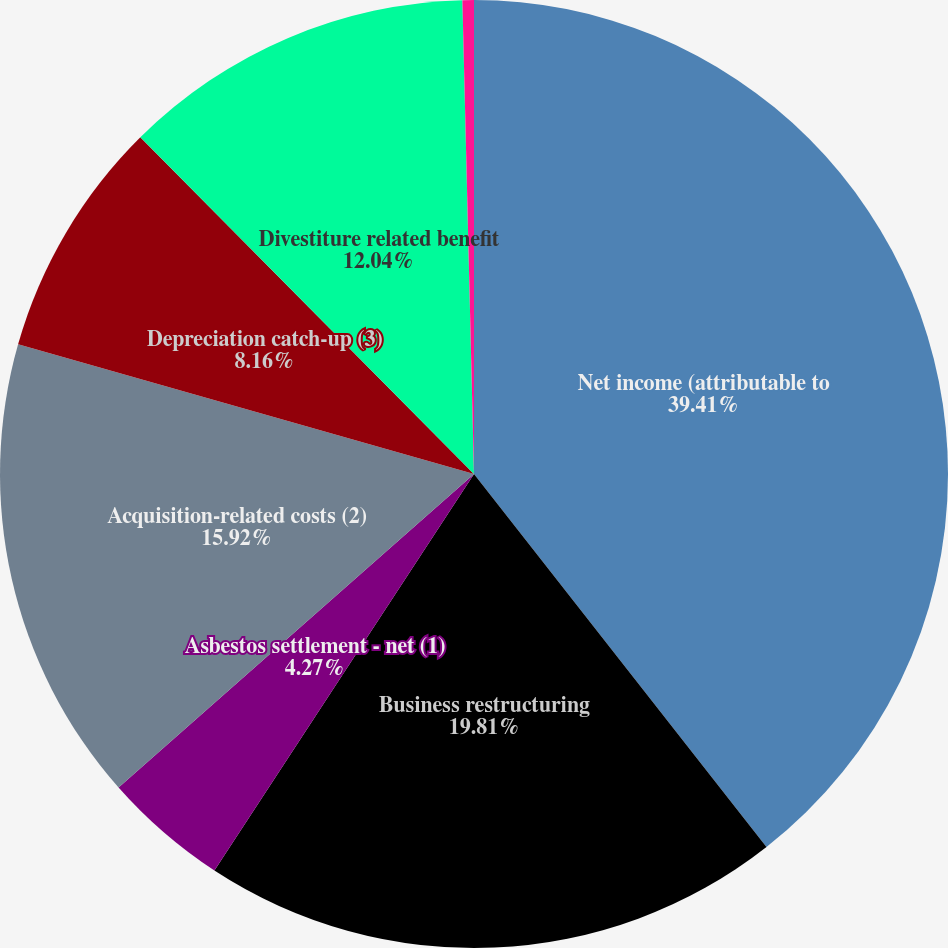<chart> <loc_0><loc_0><loc_500><loc_500><pie_chart><fcel>Net income (attributable to<fcel>Business restructuring<fcel>Asbestos settlement - net (1)<fcel>Acquisition-related costs (2)<fcel>Depreciation catch-up (3)<fcel>Divestiture related benefit<fcel>Gain on divestiture of<nl><fcel>39.42%<fcel>19.81%<fcel>4.27%<fcel>15.92%<fcel>8.16%<fcel>12.04%<fcel>0.39%<nl></chart> 